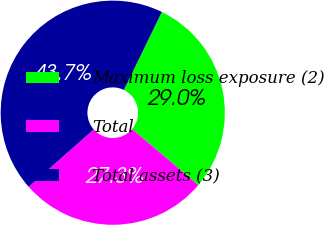<chart> <loc_0><loc_0><loc_500><loc_500><pie_chart><fcel>Maximum loss exposure (2)<fcel>Total<fcel>Total assets (3)<nl><fcel>28.96%<fcel>27.32%<fcel>43.72%<nl></chart> 